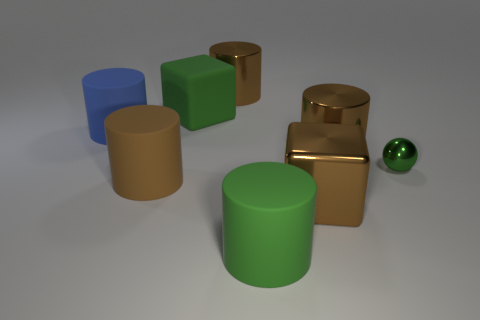How many brown objects are big things or metal balls?
Keep it short and to the point. 4. Is the number of brown shiny cubes to the left of the green cylinder the same as the number of blue cylinders?
Make the answer very short. No. What number of objects are either blue rubber things or cubes in front of the big blue matte cylinder?
Keep it short and to the point. 2. Do the tiny thing and the large matte block have the same color?
Your answer should be compact. Yes. Is there another green sphere made of the same material as the small green sphere?
Provide a short and direct response. No. Is the material of the tiny object the same as the brown cylinder in front of the small metallic thing?
Provide a succinct answer. No. What shape is the large blue rubber thing in front of the big object behind the green rubber block?
Your answer should be very brief. Cylinder. Is the size of the cube in front of the rubber cube the same as the large blue cylinder?
Your answer should be very brief. Yes. What number of other objects are there of the same shape as the blue matte thing?
Make the answer very short. 4. There is a large shiny thing in front of the green metallic sphere; is its color the same as the matte cube?
Your answer should be very brief. No. 